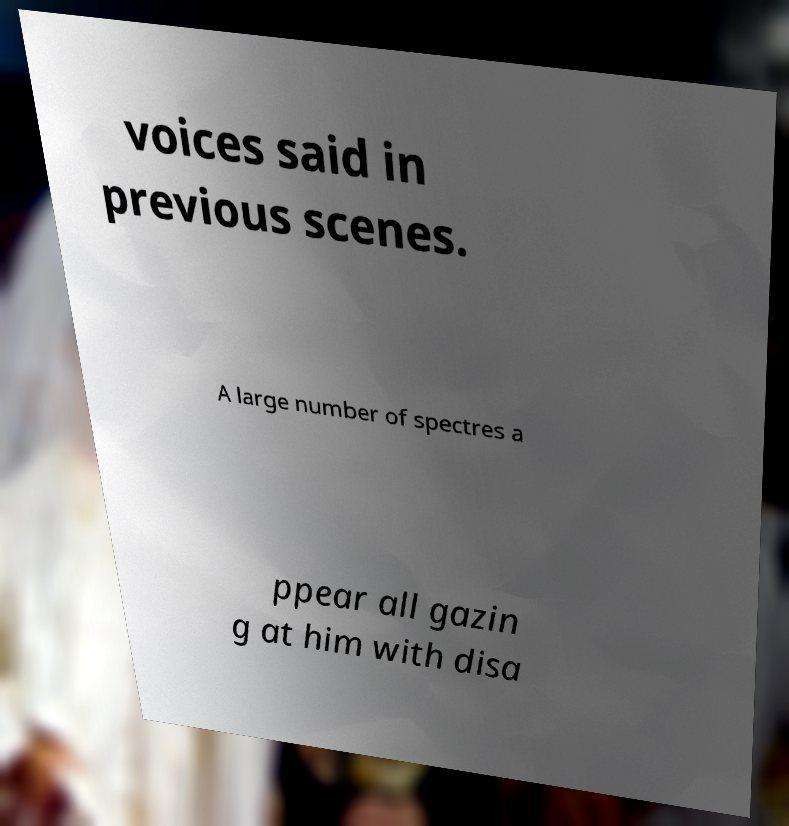There's text embedded in this image that I need extracted. Can you transcribe it verbatim? voices said in previous scenes. A large number of spectres a ppear all gazin g at him with disa 